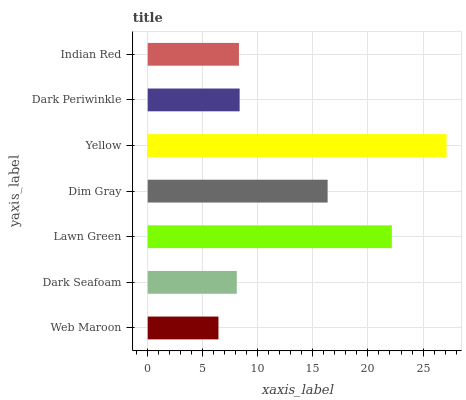Is Web Maroon the minimum?
Answer yes or no. Yes. Is Yellow the maximum?
Answer yes or no. Yes. Is Dark Seafoam the minimum?
Answer yes or no. No. Is Dark Seafoam the maximum?
Answer yes or no. No. Is Dark Seafoam greater than Web Maroon?
Answer yes or no. Yes. Is Web Maroon less than Dark Seafoam?
Answer yes or no. Yes. Is Web Maroon greater than Dark Seafoam?
Answer yes or no. No. Is Dark Seafoam less than Web Maroon?
Answer yes or no. No. Is Dark Periwinkle the high median?
Answer yes or no. Yes. Is Dark Periwinkle the low median?
Answer yes or no. Yes. Is Lawn Green the high median?
Answer yes or no. No. Is Indian Red the low median?
Answer yes or no. No. 